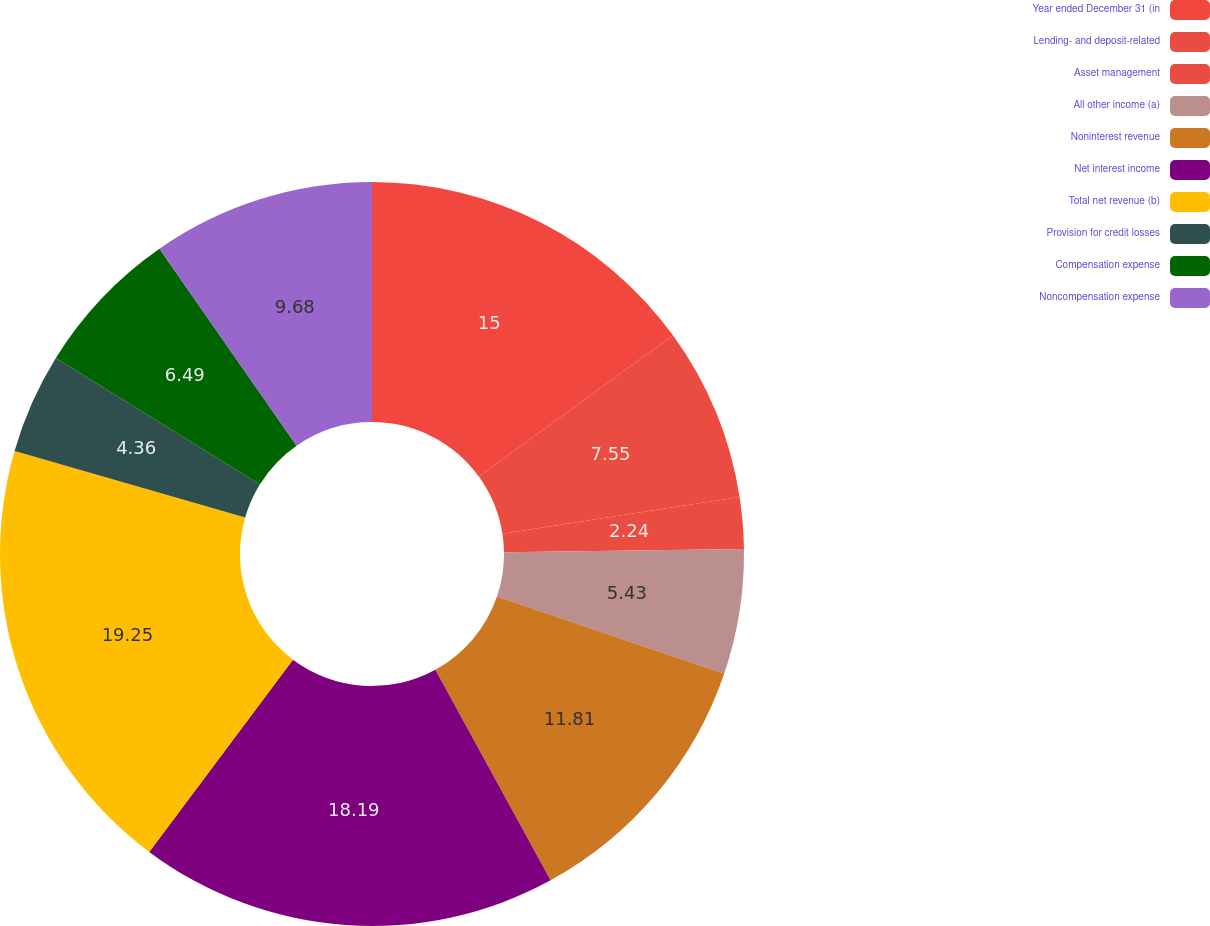Convert chart. <chart><loc_0><loc_0><loc_500><loc_500><pie_chart><fcel>Year ended December 31 (in<fcel>Lending- and deposit-related<fcel>Asset management<fcel>All other income (a)<fcel>Noninterest revenue<fcel>Net interest income<fcel>Total net revenue (b)<fcel>Provision for credit losses<fcel>Compensation expense<fcel>Noncompensation expense<nl><fcel>15.0%<fcel>7.55%<fcel>2.24%<fcel>5.43%<fcel>11.81%<fcel>18.19%<fcel>19.25%<fcel>4.36%<fcel>6.49%<fcel>9.68%<nl></chart> 